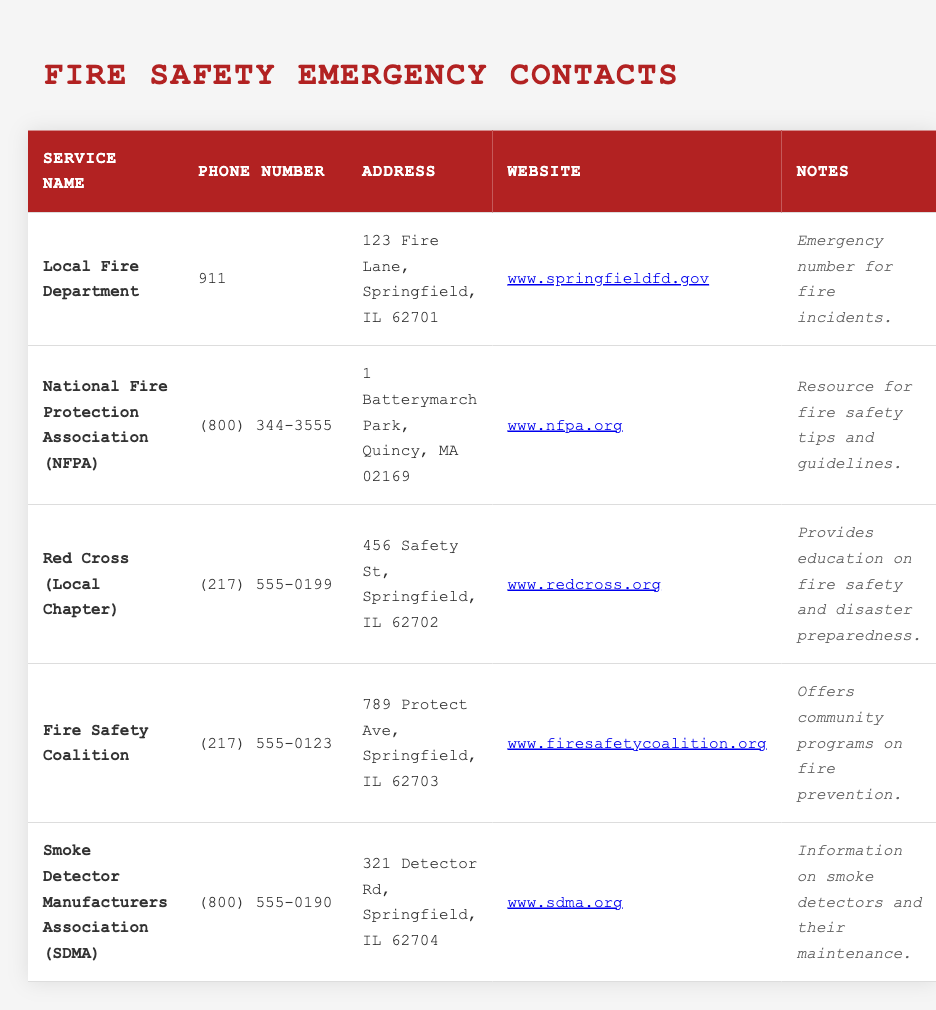What is the phone number for the Local Fire Department? The table lists the Local Fire Department's phone number in the second column. It is shown as "911".
Answer: 911 What is the address of the National Fire Protection Association (NFPA)? To find the address of NFPA, check the third column of the corresponding row. It shows "1 Batterymarch Park, Quincy, MA 02169".
Answer: 1 Batterymarch Park, Quincy, MA 02169 Does the Red Cross provide education on fire safety? The note for the Red Cross in the last column states that it "Provides education on fire safety and disaster preparedness," which answers the question affirmatively.
Answer: Yes How many services listed have a phone number that starts with (800)? The first step is to scan the phone number column and count how many numbers begin with (800). In the table, there are two such entries: NFPA and SDMA. Therefore, the total count is 2.
Answer: 2 What is the website URL for the Fire Safety Coalition? To obtain the website for the Fire Safety Coalition, refer to the table and locate the URL in the fourth column of the corresponding row, which is "http://www.firesafetycoalition.org".
Answer: http://www.firesafetycoalition.org Which service provides community programs on fire prevention? By looking at the notes column, we find that the Fire Safety Coalition specifically offers community programs on fire prevention. This is stated in the corresponding entry in the last column.
Answer: Fire Safety Coalition If I had an emergency, which phone number would I call? The emergency phone number is found in the entry for the Local Fire Department, listed as "911" in the table. In an emergency, this is the number to dial.
Answer: 911 Is there a service dedicated solely to smoke detectors? The Smoke Detector Manufacturers Association (SDMA) is mentioned in the table, and its notes indicate it provides information specifically about smoke detectors and their maintenance. Thus, it is dedicated to smoke detectors.
Answer: Yes How many organizations are located in Springfield, IL? Analyzing the addresses in the table, there are three organizations located in Springfield, IL: the Local Fire Department, Red Cross, and Fire Safety Coalition. Count each of them: 3.
Answer: 3 What type of organization is the NFPA? The NFPA is described as a resource for fire safety tips and guidelines, which indicates it functions as an educational and safety advocacy organization.
Answer: Educational organization on fire safety 